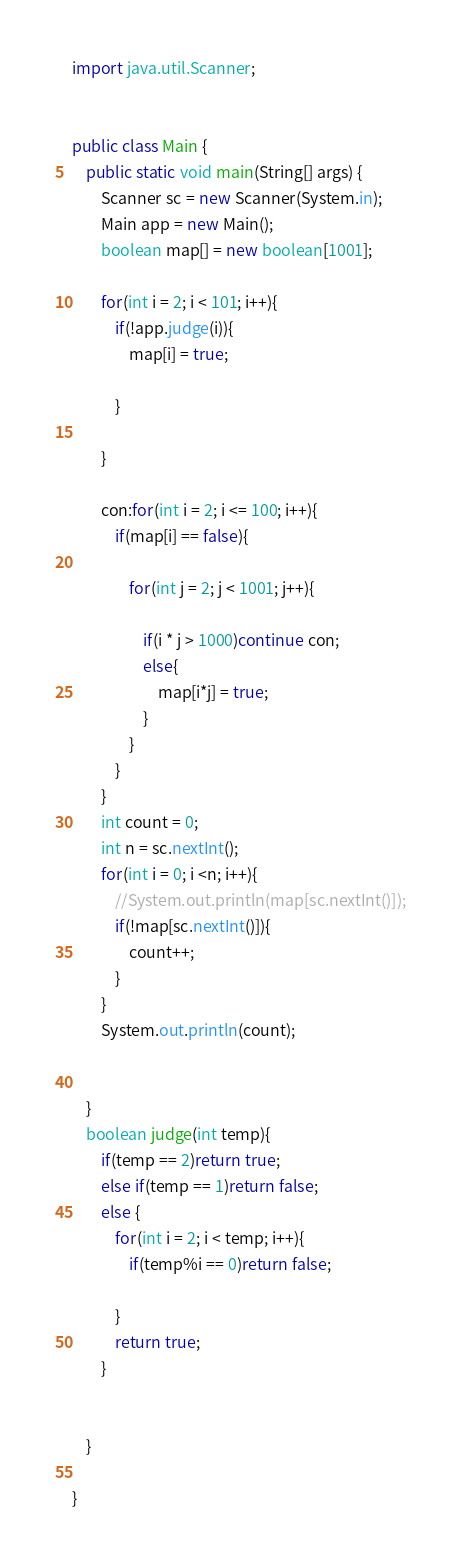Convert code to text. <code><loc_0><loc_0><loc_500><loc_500><_Java_>import java.util.Scanner;


public class Main {
	public static void main(String[] args) {
		Scanner sc = new Scanner(System.in);
		Main app = new Main();
		boolean map[] = new boolean[1001];
		
		for(int i = 2; i < 101; i++){
			if(!app.judge(i)){
				map[i] = true;
				
			}
			
		}
		
		con:for(int i = 2; i <= 100; i++){
			if(map[i] == false){

				for(int j = 2; j < 1001; j++){
				
					if(i * j > 1000)continue con;
					else{
						map[i*j] = true;
					}
				}
			}
		}
		int count = 0;
		int n = sc.nextInt();
		for(int i = 0; i <n; i++){
			//System.out.println(map[sc.nextInt()]);
			if(!map[sc.nextInt()]){
				count++;
			}
		}
		System.out.println(count);
		
		
	}
	boolean judge(int temp){
		if(temp == 2)return true;
		else if(temp == 1)return false;
		else {
			for(int i = 2; i < temp; i++){
				if(temp%i == 0)return false;

			}
			return true;
		}
		
			
	}

}</code> 